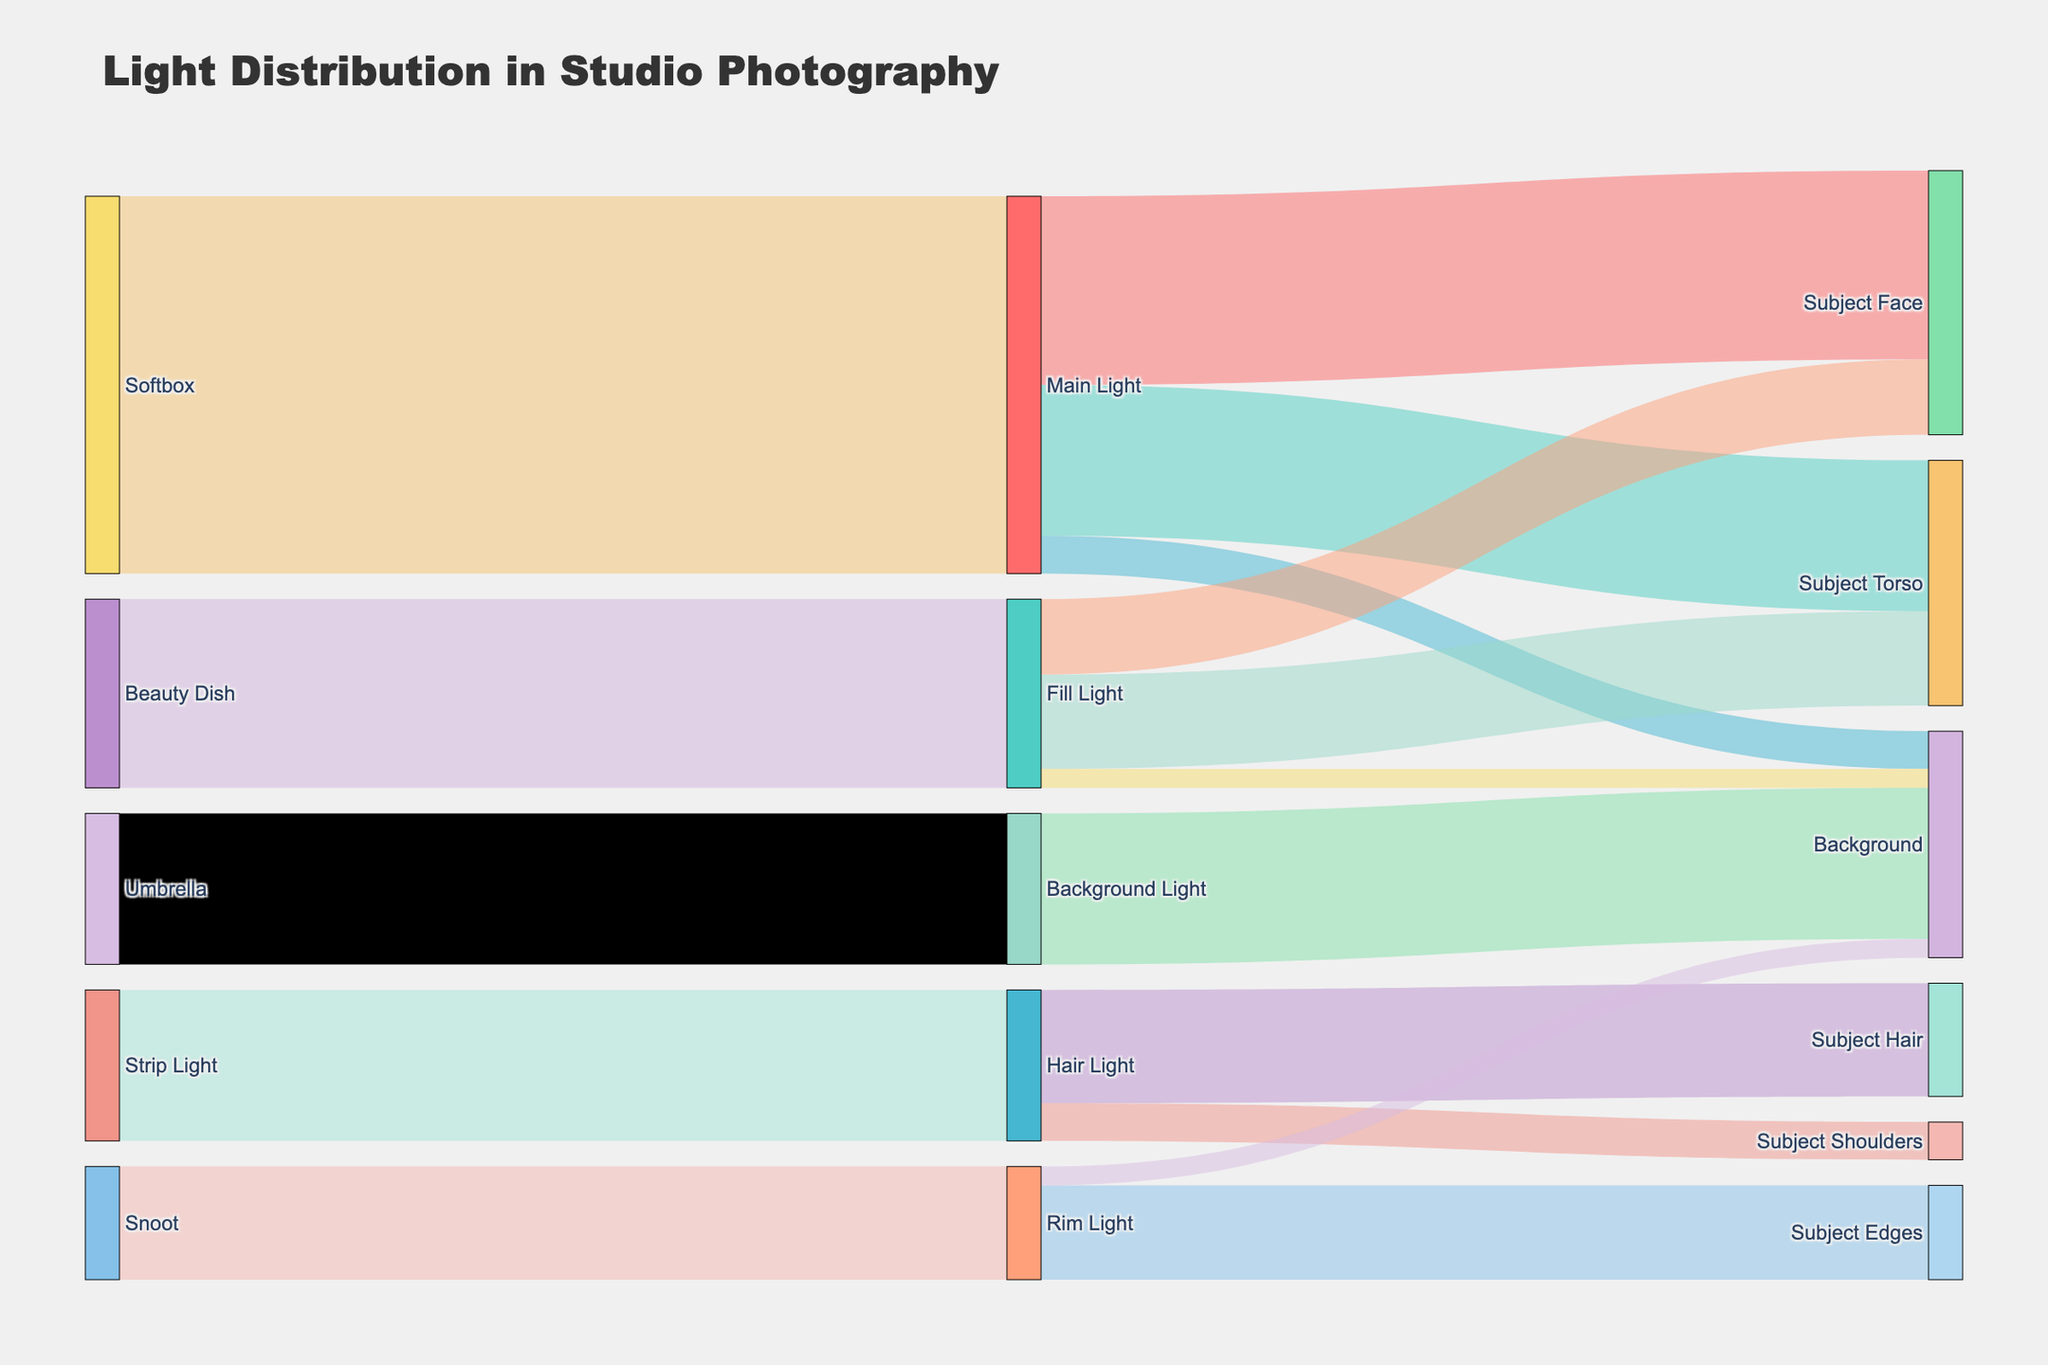How many different light sources are there? The Sankey Diagram shows the flow coming from multiple light sources. Count the number of different sources labeled in the diagram and check their individual link paths.
Answer: 6 Which light source is contributing the most to the Subject Face? To find the light source contributing most to the Subject Face, look at the links that connect to the Subject Face. The values for each link to the Subject Face are provided. The Main Light contributes 50 units, while the Fill Light contributes 20 units.
Answer: Main Light What is the total amount of light directed to the Background? To determine the total light directed to the Background, sum up all values in the links that lead to it: Main Light (10 units), Fill Light (5 units), Rim Light (5 units), and Background Light (40 units). 10 + 5 + 5 + 40 = 60.
Answer: 60 How much light from the Fill Light is directed towards the Subject Torso? Locate the link path from Fill Light to the Subject Torso in the Sankey Diagram. The value provided in the link path is 25 units.
Answer: 25 Which area receives the least amount of light from the Rim Light? Examine the Sankey Diagram for the Rim Light. It has two paths: one to Subject Edges (25 units) and another to the Background (5 units). The smaller value is for the Background.
Answer: Background What is the proportion of light from Hair Light to Subject Hair compared to Subject Shoulders? Proportion can be calculated by comparing the amounts of light going to each area. The Hair Light sends 30 units to Subject Hair and 10 units to Subject Shoulders. The proportion is 30:10, which simplifies to 3:1.
Answer: 3:1 Is the amount of light from the Softbox to the Main Light greater than the total light directed to the Background? Check the value of light flow from the Softbox to the Main Light, which is 100 units. Compare this to the total light directed to the Background (60 units). 100 > 60, so the conclusion is yes.
Answer: Yes What equipment is used for the Fill Light? Follow the link paths in the Sankey Diagram to identify the equipment used for the Fill Light. The connected equipment is the Beauty Dish, with 50 units flowing into the Fill Light.
Answer: Beauty Dish Which area receives the highest total amount of light? To determine the area with the highest total light, sum the flow values for each area. Compare the sums: Subject Face (50+20), Subject Torso (40+25), Background (10+5+5+40), Subject Hair (30), Subject Shoulders (10), Subject Edges (25). Calculate sums: 70, 65, 60, 30, 10, 25. The maximum is 70 (Subject Face).
Answer: Subject Face 